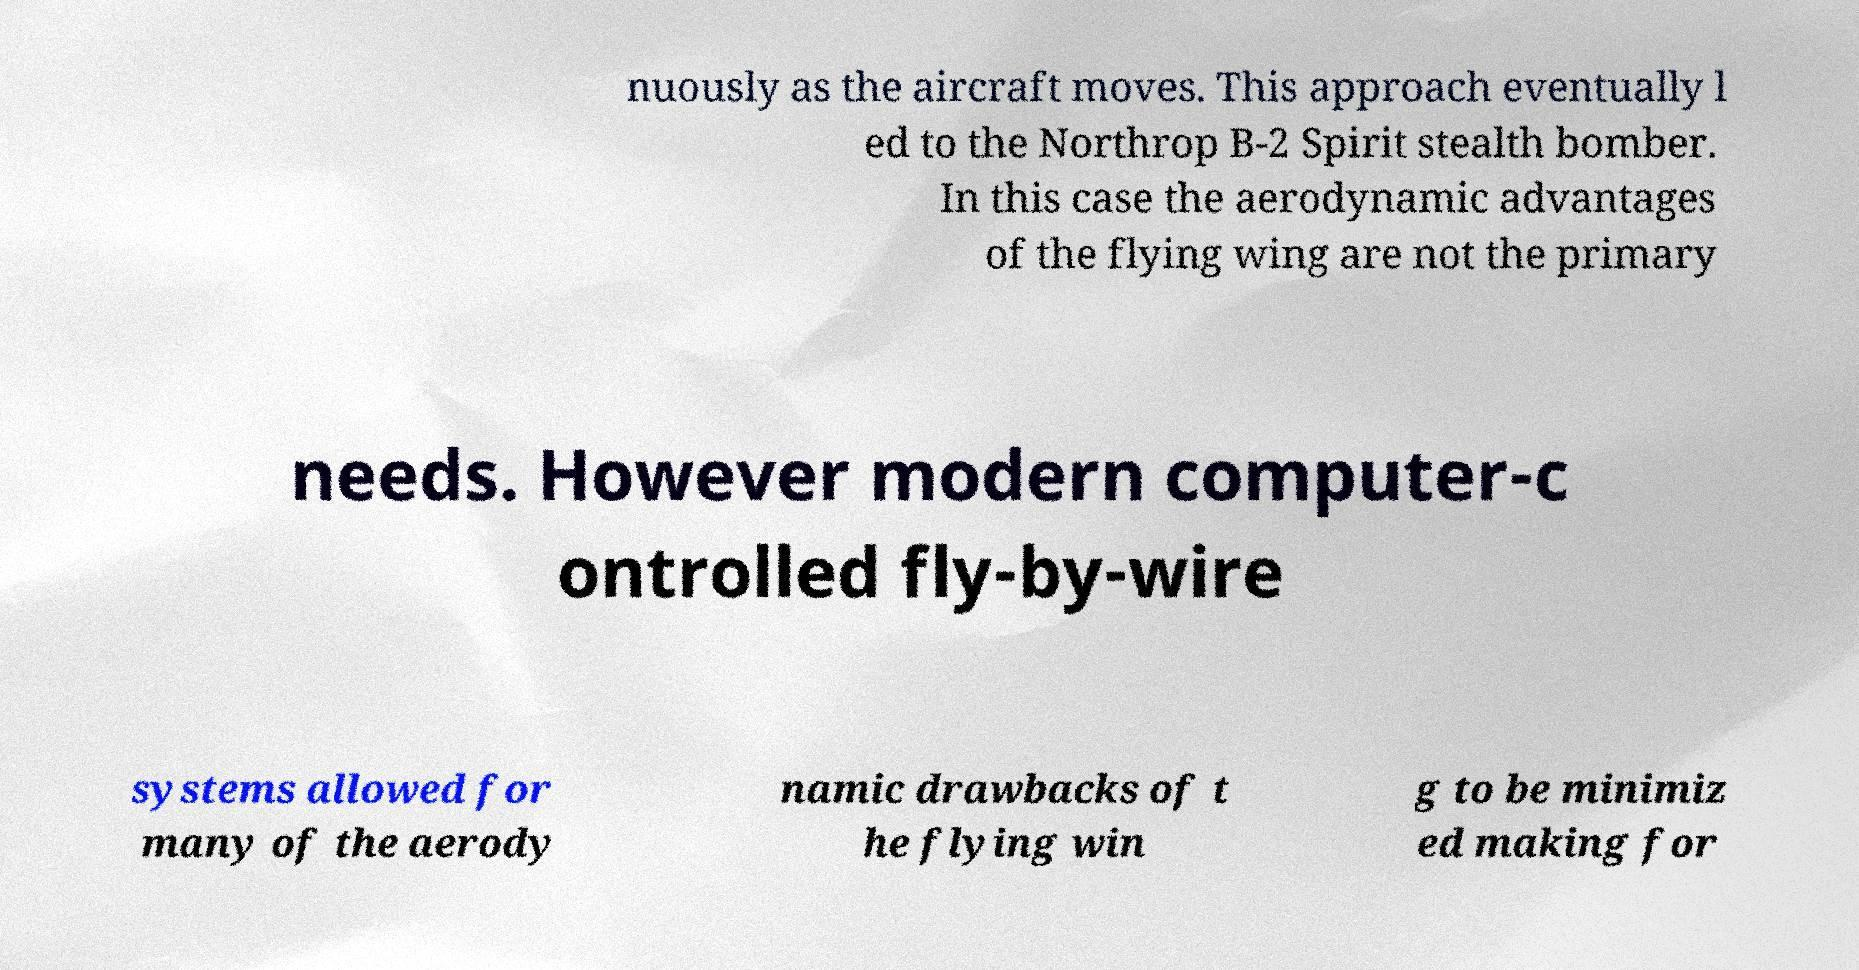I need the written content from this picture converted into text. Can you do that? nuously as the aircraft moves. This approach eventually l ed to the Northrop B-2 Spirit stealth bomber. In this case the aerodynamic advantages of the flying wing are not the primary needs. However modern computer-c ontrolled fly-by-wire systems allowed for many of the aerody namic drawbacks of t he flying win g to be minimiz ed making for 